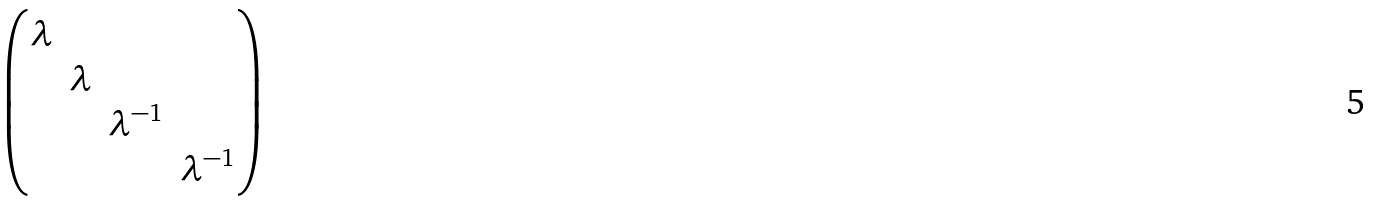Convert formula to latex. <formula><loc_0><loc_0><loc_500><loc_500>\begin{pmatrix} \lambda & & & \\ & \lambda & & \\ & & \lambda ^ { - 1 } & \\ & & & \lambda ^ { - 1 } \end{pmatrix}</formula> 